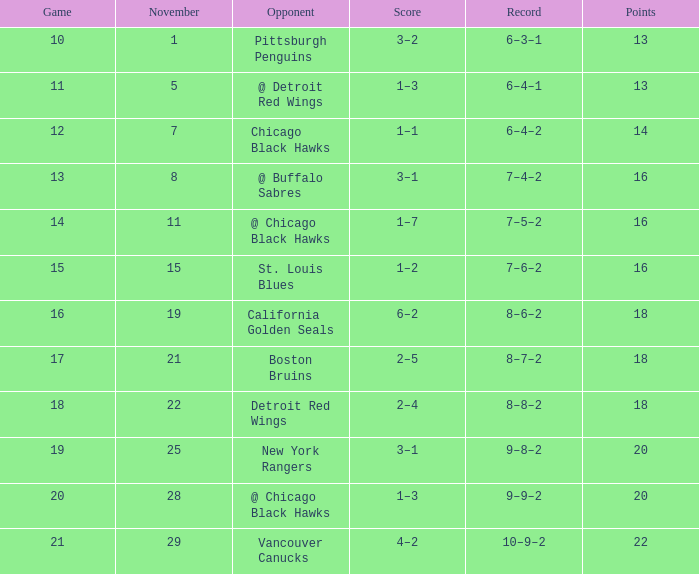Which record has a november larger than 11, and st. louis blues as the opposition? 7–6–2. 